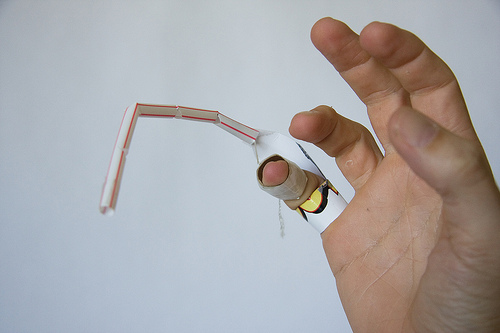<image>
Is the finger on the straw? No. The finger is not positioned on the straw. They may be near each other, but the finger is not supported by or resting on top of the straw. 